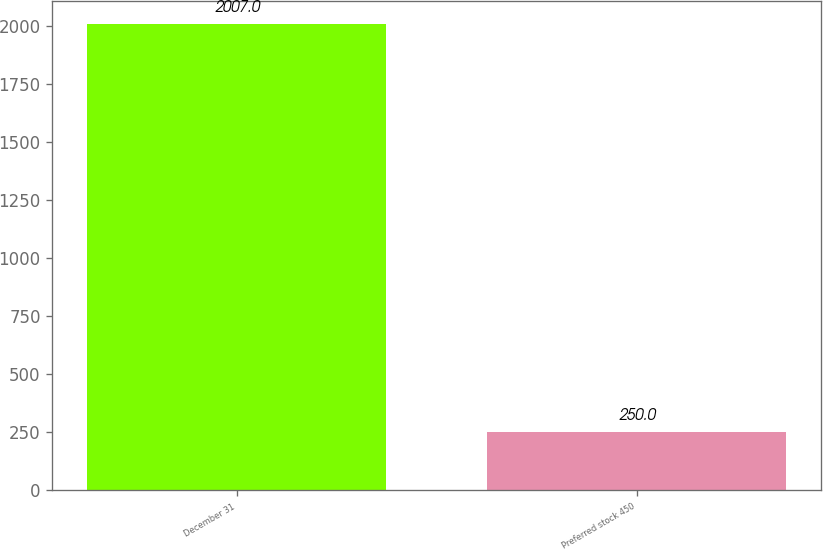Convert chart. <chart><loc_0><loc_0><loc_500><loc_500><bar_chart><fcel>December 31<fcel>Preferred stock 450<nl><fcel>2007<fcel>250<nl></chart> 